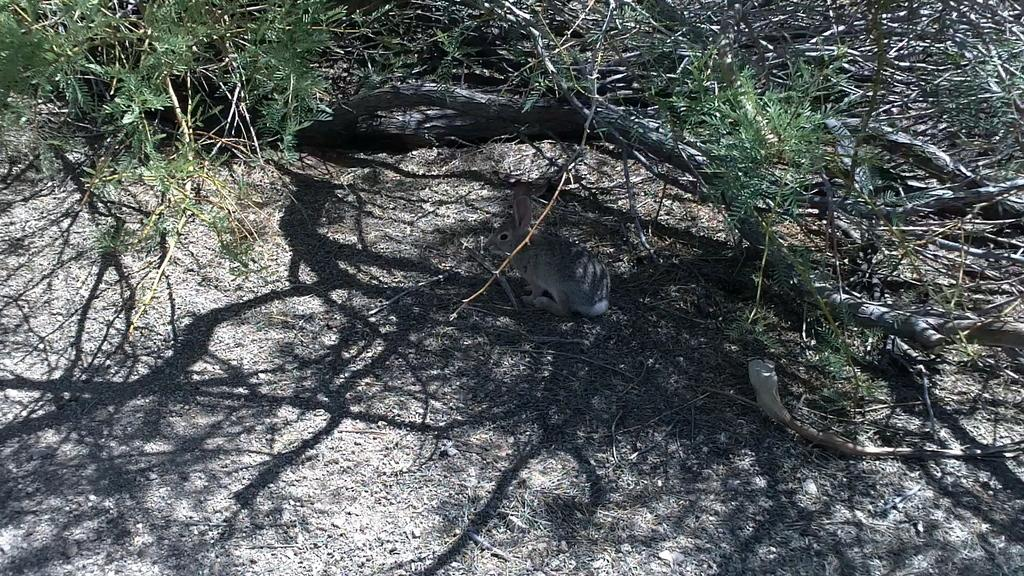What type of animal is in the image? There is a rabbit in the image. What can be seen in the background of the image? There are branches of trees with leaves in the image. What type of soap is being used to clean the plants in the image? There are no plants or soap present in the image; it only features a rabbit and branches of trees with leaves. 